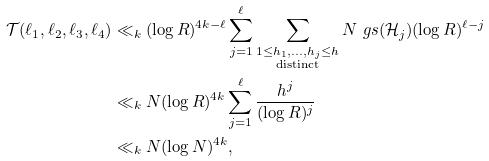Convert formula to latex. <formula><loc_0><loc_0><loc_500><loc_500>\mathcal { T } ( \ell _ { 1 } , \ell _ { 2 } , \ell _ { 3 } , \ell _ { 4 } ) & \ll _ { k } ( \log R ) ^ { 4 k - \ell } \sum _ { j = 1 } ^ { \ell } \sum _ { \substack { 1 \leq h _ { 1 } , \dots , h _ { j } \leq h \\ \text {distinct} } } N \ g s ( \mathcal { H } _ { j } ) ( \log R ) ^ { \ell - j } \\ & \ll _ { k } N ( \log R ) ^ { 4 k } \sum _ { j = 1 } ^ { \ell } \frac { h ^ { j } } { ( \log R ) ^ { j } } \\ & \ll _ { k } N ( \log N ) ^ { 4 k } ,</formula> 